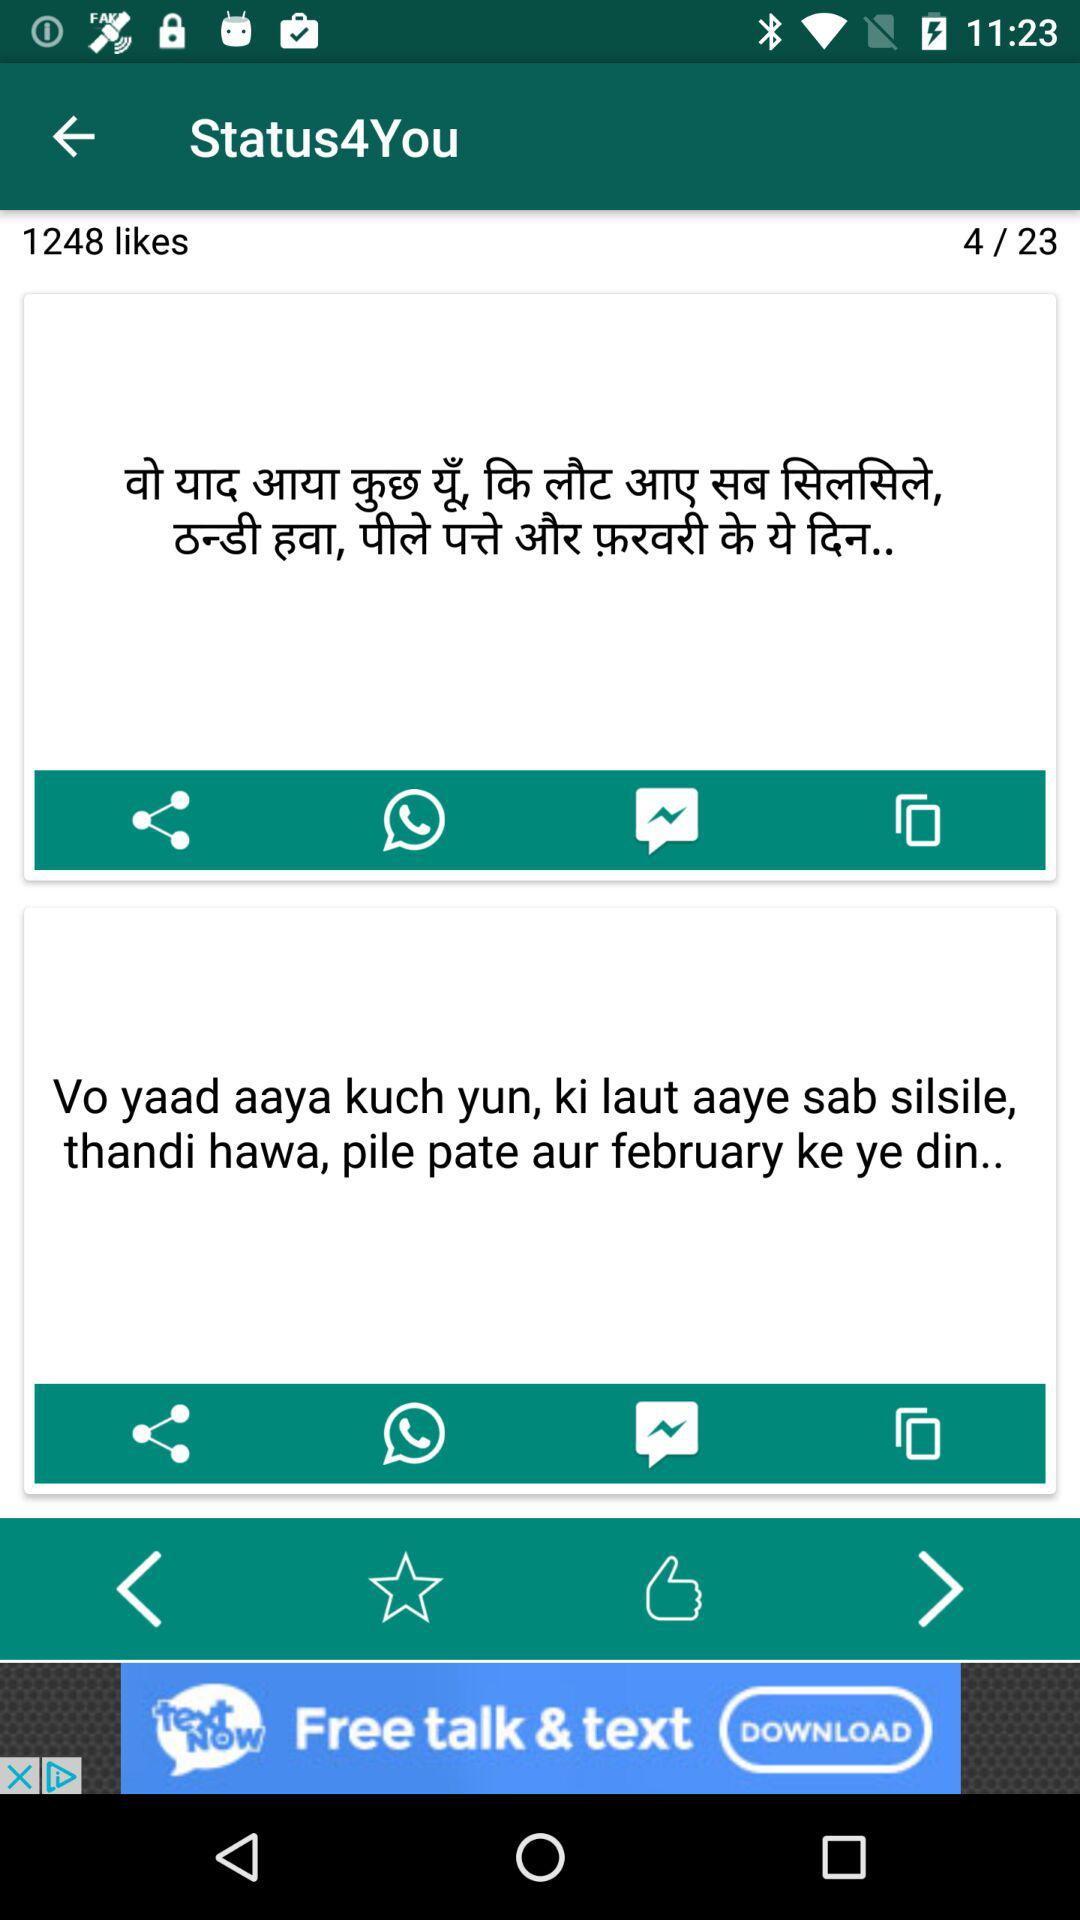On which page number am I now? You are now on the page number 4. 